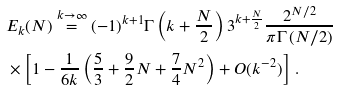<formula> <loc_0><loc_0><loc_500><loc_500>& E _ { k } ( N ) \overset { k \rightarrow \infty } { = } ( - 1 ) ^ { k + 1 } \Gamma \left ( k + \frac { N } { 2 } \right ) 3 ^ { k + \frac { N } { 2 } } \frac { 2 ^ { N / 2 } } { \pi \Gamma \left ( N / 2 \right ) } \\ & \times \left [ 1 - \frac { 1 } { 6 k } \left ( \frac { 5 } { 3 } + \frac { 9 } { 2 } N + \frac { 7 } { 4 } N ^ { 2 } \right ) + O ( k ^ { - 2 } ) \right ] \, .</formula> 